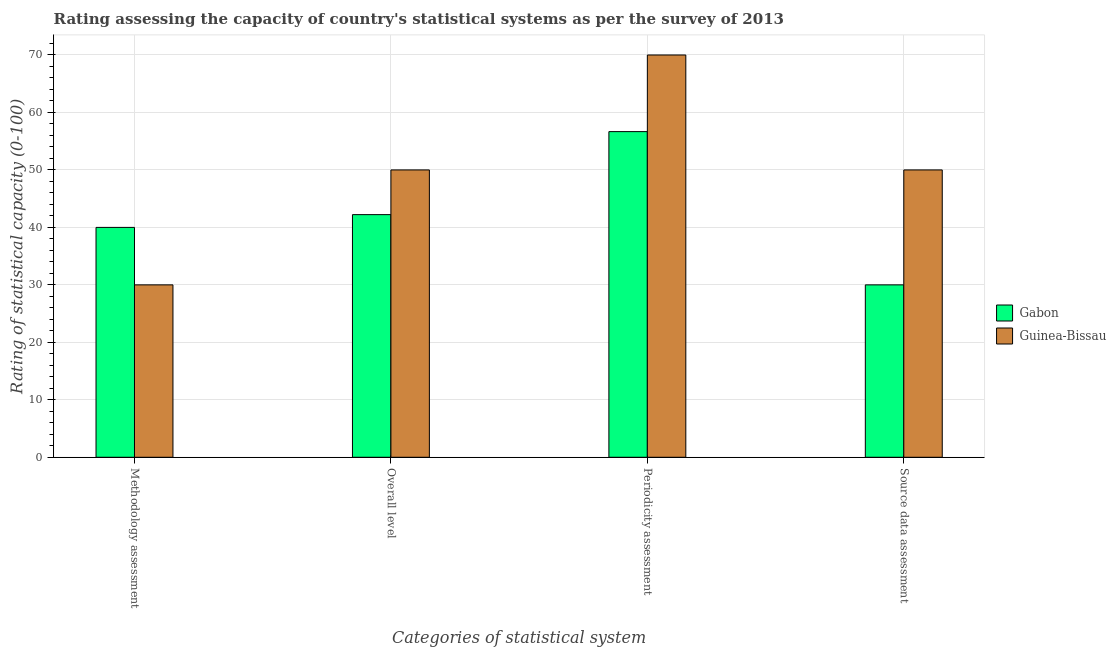Are the number of bars per tick equal to the number of legend labels?
Your answer should be compact. Yes. Are the number of bars on each tick of the X-axis equal?
Your response must be concise. Yes. How many bars are there on the 2nd tick from the left?
Offer a terse response. 2. What is the label of the 1st group of bars from the left?
Keep it short and to the point. Methodology assessment. What is the methodology assessment rating in Gabon?
Keep it short and to the point. 40. Across all countries, what is the maximum source data assessment rating?
Make the answer very short. 50. Across all countries, what is the minimum periodicity assessment rating?
Your answer should be compact. 56.67. In which country was the methodology assessment rating maximum?
Give a very brief answer. Gabon. In which country was the methodology assessment rating minimum?
Ensure brevity in your answer.  Guinea-Bissau. What is the total overall level rating in the graph?
Your answer should be compact. 92.22. What is the difference between the overall level rating in Guinea-Bissau and that in Gabon?
Offer a very short reply. 7.78. What is the difference between the periodicity assessment rating in Gabon and the source data assessment rating in Guinea-Bissau?
Provide a short and direct response. 6.67. What is the difference between the overall level rating and methodology assessment rating in Gabon?
Offer a very short reply. 2.22. In how many countries, is the overall level rating greater than 42 ?
Provide a succinct answer. 2. Is the periodicity assessment rating in Guinea-Bissau less than that in Gabon?
Provide a short and direct response. No. Is the difference between the methodology assessment rating in Guinea-Bissau and Gabon greater than the difference between the periodicity assessment rating in Guinea-Bissau and Gabon?
Make the answer very short. No. What is the difference between the highest and the second highest overall level rating?
Offer a very short reply. 7.78. What is the difference between the highest and the lowest overall level rating?
Offer a very short reply. 7.78. Is the sum of the overall level rating in Guinea-Bissau and Gabon greater than the maximum methodology assessment rating across all countries?
Your answer should be compact. Yes. Is it the case that in every country, the sum of the methodology assessment rating and source data assessment rating is greater than the sum of periodicity assessment rating and overall level rating?
Provide a short and direct response. No. What does the 1st bar from the left in Overall level represents?
Provide a short and direct response. Gabon. What does the 2nd bar from the right in Methodology assessment represents?
Provide a short and direct response. Gabon. Are all the bars in the graph horizontal?
Your answer should be very brief. No. How many countries are there in the graph?
Your answer should be compact. 2. Are the values on the major ticks of Y-axis written in scientific E-notation?
Provide a succinct answer. No. Does the graph contain any zero values?
Ensure brevity in your answer.  No. Does the graph contain grids?
Your answer should be compact. Yes. Where does the legend appear in the graph?
Provide a succinct answer. Center right. How many legend labels are there?
Make the answer very short. 2. How are the legend labels stacked?
Your answer should be compact. Vertical. What is the title of the graph?
Ensure brevity in your answer.  Rating assessing the capacity of country's statistical systems as per the survey of 2013 . What is the label or title of the X-axis?
Provide a short and direct response. Categories of statistical system. What is the label or title of the Y-axis?
Your answer should be very brief. Rating of statistical capacity (0-100). What is the Rating of statistical capacity (0-100) in Guinea-Bissau in Methodology assessment?
Your answer should be compact. 30. What is the Rating of statistical capacity (0-100) of Gabon in Overall level?
Your answer should be compact. 42.22. What is the Rating of statistical capacity (0-100) of Gabon in Periodicity assessment?
Offer a terse response. 56.67. What is the Rating of statistical capacity (0-100) of Guinea-Bissau in Periodicity assessment?
Keep it short and to the point. 70. What is the Rating of statistical capacity (0-100) in Guinea-Bissau in Source data assessment?
Offer a very short reply. 50. Across all Categories of statistical system, what is the maximum Rating of statistical capacity (0-100) of Gabon?
Provide a succinct answer. 56.67. Across all Categories of statistical system, what is the minimum Rating of statistical capacity (0-100) in Gabon?
Your answer should be very brief. 30. Across all Categories of statistical system, what is the minimum Rating of statistical capacity (0-100) of Guinea-Bissau?
Provide a short and direct response. 30. What is the total Rating of statistical capacity (0-100) in Gabon in the graph?
Give a very brief answer. 168.89. What is the total Rating of statistical capacity (0-100) of Guinea-Bissau in the graph?
Make the answer very short. 200. What is the difference between the Rating of statistical capacity (0-100) of Gabon in Methodology assessment and that in Overall level?
Keep it short and to the point. -2.22. What is the difference between the Rating of statistical capacity (0-100) of Guinea-Bissau in Methodology assessment and that in Overall level?
Offer a terse response. -20. What is the difference between the Rating of statistical capacity (0-100) in Gabon in Methodology assessment and that in Periodicity assessment?
Make the answer very short. -16.67. What is the difference between the Rating of statistical capacity (0-100) of Gabon in Methodology assessment and that in Source data assessment?
Offer a very short reply. 10. What is the difference between the Rating of statistical capacity (0-100) of Guinea-Bissau in Methodology assessment and that in Source data assessment?
Provide a succinct answer. -20. What is the difference between the Rating of statistical capacity (0-100) of Gabon in Overall level and that in Periodicity assessment?
Your answer should be compact. -14.44. What is the difference between the Rating of statistical capacity (0-100) in Guinea-Bissau in Overall level and that in Periodicity assessment?
Ensure brevity in your answer.  -20. What is the difference between the Rating of statistical capacity (0-100) of Gabon in Overall level and that in Source data assessment?
Provide a succinct answer. 12.22. What is the difference between the Rating of statistical capacity (0-100) of Gabon in Periodicity assessment and that in Source data assessment?
Your answer should be compact. 26.67. What is the difference between the Rating of statistical capacity (0-100) of Guinea-Bissau in Periodicity assessment and that in Source data assessment?
Keep it short and to the point. 20. What is the difference between the Rating of statistical capacity (0-100) of Gabon in Overall level and the Rating of statistical capacity (0-100) of Guinea-Bissau in Periodicity assessment?
Give a very brief answer. -27.78. What is the difference between the Rating of statistical capacity (0-100) of Gabon in Overall level and the Rating of statistical capacity (0-100) of Guinea-Bissau in Source data assessment?
Your answer should be very brief. -7.78. What is the difference between the Rating of statistical capacity (0-100) of Gabon in Periodicity assessment and the Rating of statistical capacity (0-100) of Guinea-Bissau in Source data assessment?
Provide a succinct answer. 6.67. What is the average Rating of statistical capacity (0-100) in Gabon per Categories of statistical system?
Provide a short and direct response. 42.22. What is the difference between the Rating of statistical capacity (0-100) in Gabon and Rating of statistical capacity (0-100) in Guinea-Bissau in Overall level?
Ensure brevity in your answer.  -7.78. What is the difference between the Rating of statistical capacity (0-100) in Gabon and Rating of statistical capacity (0-100) in Guinea-Bissau in Periodicity assessment?
Your response must be concise. -13.33. What is the difference between the Rating of statistical capacity (0-100) of Gabon and Rating of statistical capacity (0-100) of Guinea-Bissau in Source data assessment?
Keep it short and to the point. -20. What is the ratio of the Rating of statistical capacity (0-100) in Gabon in Methodology assessment to that in Overall level?
Your answer should be very brief. 0.95. What is the ratio of the Rating of statistical capacity (0-100) of Guinea-Bissau in Methodology assessment to that in Overall level?
Your response must be concise. 0.6. What is the ratio of the Rating of statistical capacity (0-100) in Gabon in Methodology assessment to that in Periodicity assessment?
Ensure brevity in your answer.  0.71. What is the ratio of the Rating of statistical capacity (0-100) in Guinea-Bissau in Methodology assessment to that in Periodicity assessment?
Make the answer very short. 0.43. What is the ratio of the Rating of statistical capacity (0-100) in Guinea-Bissau in Methodology assessment to that in Source data assessment?
Your response must be concise. 0.6. What is the ratio of the Rating of statistical capacity (0-100) of Gabon in Overall level to that in Periodicity assessment?
Ensure brevity in your answer.  0.75. What is the ratio of the Rating of statistical capacity (0-100) in Gabon in Overall level to that in Source data assessment?
Ensure brevity in your answer.  1.41. What is the ratio of the Rating of statistical capacity (0-100) in Gabon in Periodicity assessment to that in Source data assessment?
Your response must be concise. 1.89. What is the difference between the highest and the second highest Rating of statistical capacity (0-100) in Gabon?
Offer a terse response. 14.44. What is the difference between the highest and the second highest Rating of statistical capacity (0-100) of Guinea-Bissau?
Provide a succinct answer. 20. What is the difference between the highest and the lowest Rating of statistical capacity (0-100) of Gabon?
Provide a short and direct response. 26.67. 